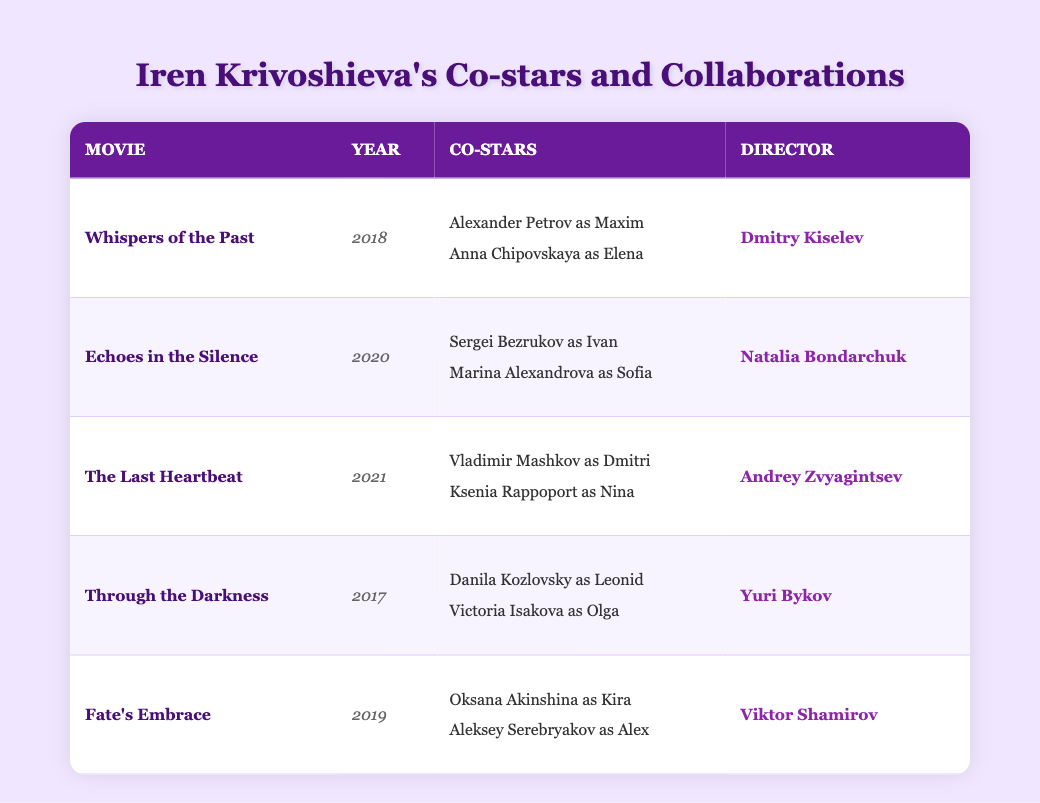What is the title of the movie released in 2021 that features Iren Krivoshieva? The table lists "The Last Heartbeat" as the movie released in 2021 featuring Iren Krivoshieva.
Answer: The Last Heartbeat Who directed "Echoes in the Silence"? According to the table, "Echoes in the Silence" was directed by Natalia Bondarchuk.
Answer: Natalia Bondarchuk What roles did the co-stars play in the movie "Fate's Embrace"? The table indicates that Oksana Akinshina played Kira and Aleksey Serebryakov played Alex in "Fate's Embrace".
Answer: Kira and Alex How many movies has Iren Krivoshieva collaborated in between 2017 and 2021? The table shows that there are five movies listed. These are "Through the Darkness" (2017), "Whispers of the Past" (2018), "Fate's Embrace" (2019), "Echoes in the Silence" (2020), and "The Last Heartbeat" (2021), totaling five movies.
Answer: 5 Did Iren Krivoshieva co-star with Sergei Bezrukov in any of her movies? Yes, the table shows that she co-starred with Sergei Bezrukov in "Echoes in the Silence".
Answer: Yes Which movie had the most recent release year listed in the table, and who was its director? The most recent release year is 2021 for "The Last Heartbeat," which was directed by Andrey Zvyagintsev.
Answer: The Last Heartbeat, Andrey Zvyagintsev Which director worked on more than one film with Iren Krivoshieva? The table does not indicate any director working on more than one film with Iren Krivoshieva, as each film listed is directed by a different individual.
Answer: No director worked on more than one film What are the names of the co-stars in "Whispers of the Past"? The table lists Alexander Petrov as Maxim and Anna Chipovskaya as Elena as co-stars in "Whispers of the Past".
Answer: Alexander Petrov, Anna Chipovskaya Which co-star appeared in the earliest released movie alongside Iren Krivoshieva? The earliest released movie listed is "Through the Darkness" (2017) in which Danila Kozlovsky and Victoria Isakova appeared as co-stars.
Answer: Danila Kozlovsky and Victoria Isakova What is the average release year of the movies in which Iren Krivoshieva has collaborated based on the data? The release years are 2017, 2018, 2019, 2020, and 2021. Adding them gives 2015, and dividing by 5 results in an average of 2019.
Answer: 2019 